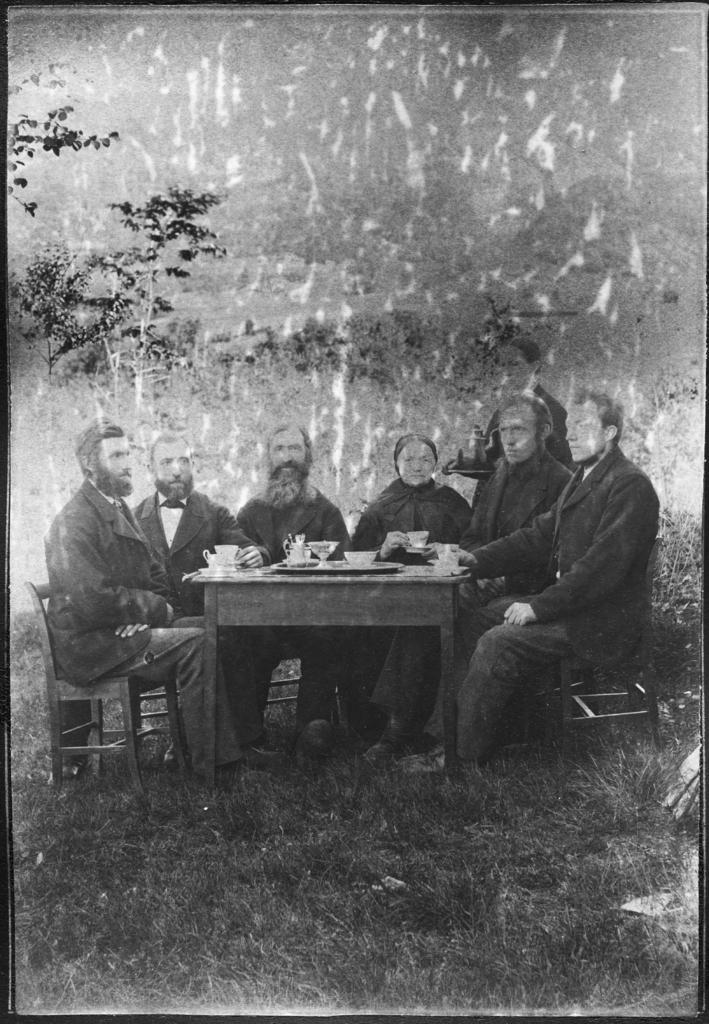Can you describe this image briefly? This is a black and white image there is grass in the bottom and table in the middle. There are chairs around the table. People sat on chairs around this table. This table has cups, plate, bowl and kettle. There is a tree on the left side. 